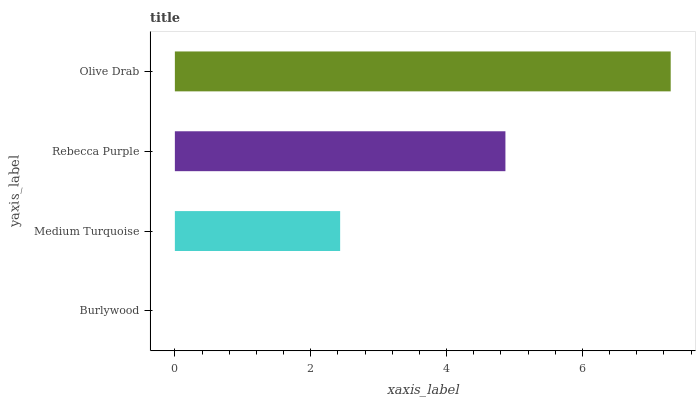Is Burlywood the minimum?
Answer yes or no. Yes. Is Olive Drab the maximum?
Answer yes or no. Yes. Is Medium Turquoise the minimum?
Answer yes or no. No. Is Medium Turquoise the maximum?
Answer yes or no. No. Is Medium Turquoise greater than Burlywood?
Answer yes or no. Yes. Is Burlywood less than Medium Turquoise?
Answer yes or no. Yes. Is Burlywood greater than Medium Turquoise?
Answer yes or no. No. Is Medium Turquoise less than Burlywood?
Answer yes or no. No. Is Rebecca Purple the high median?
Answer yes or no. Yes. Is Medium Turquoise the low median?
Answer yes or no. Yes. Is Burlywood the high median?
Answer yes or no. No. Is Rebecca Purple the low median?
Answer yes or no. No. 